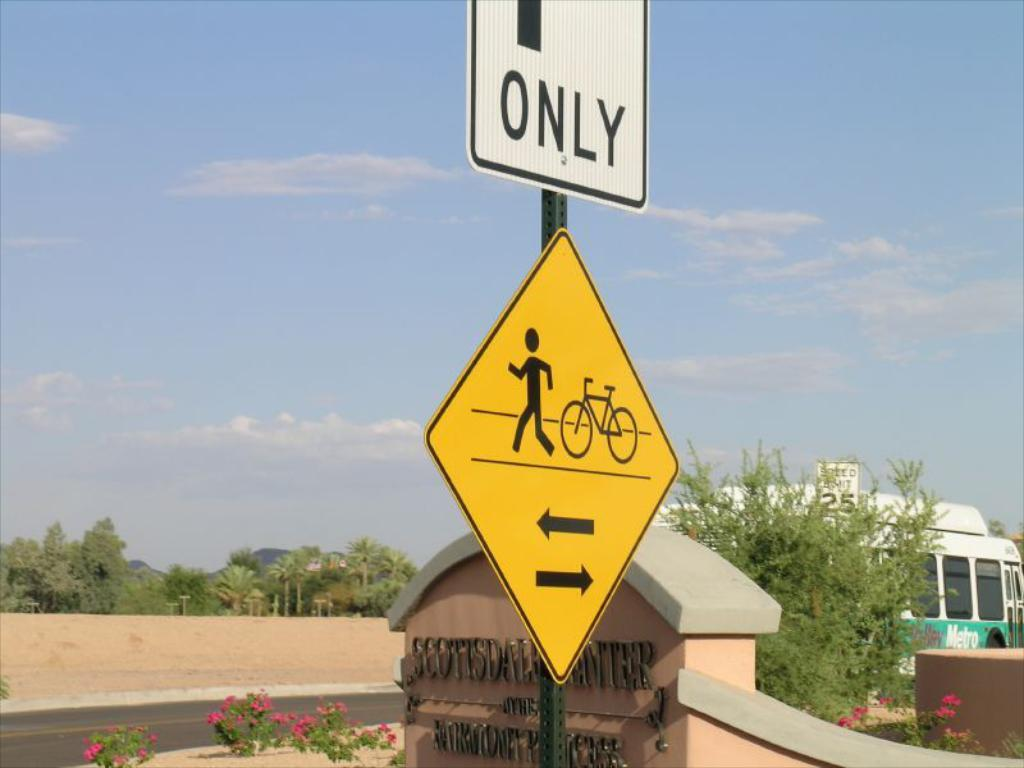<image>
Create a compact narrative representing the image presented. A white sign on which the word ONLY is visible, above a yellow and black sign with a picture of a man and a bike. 